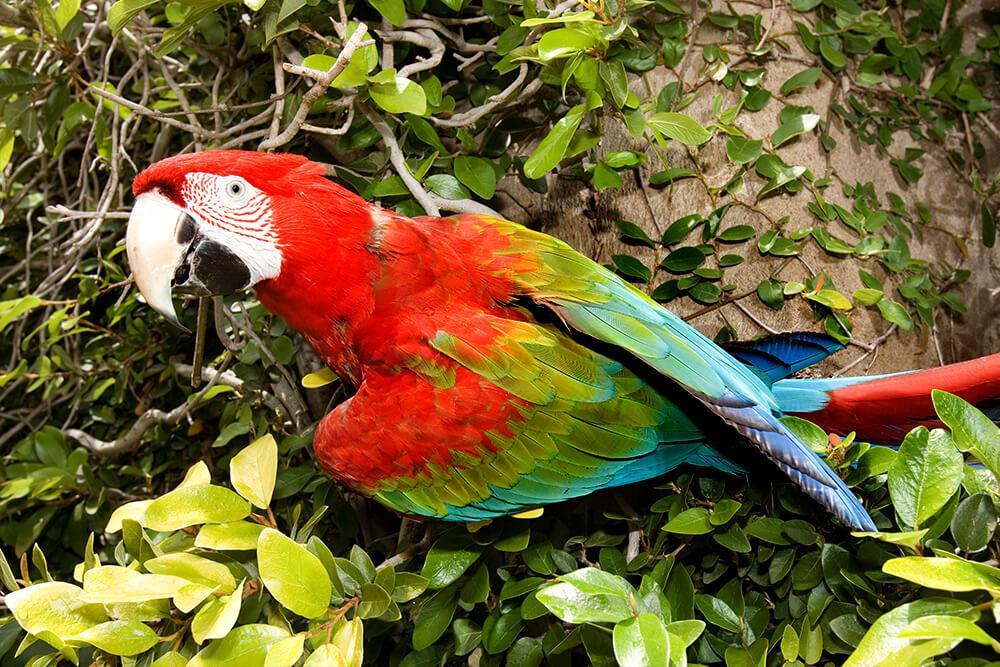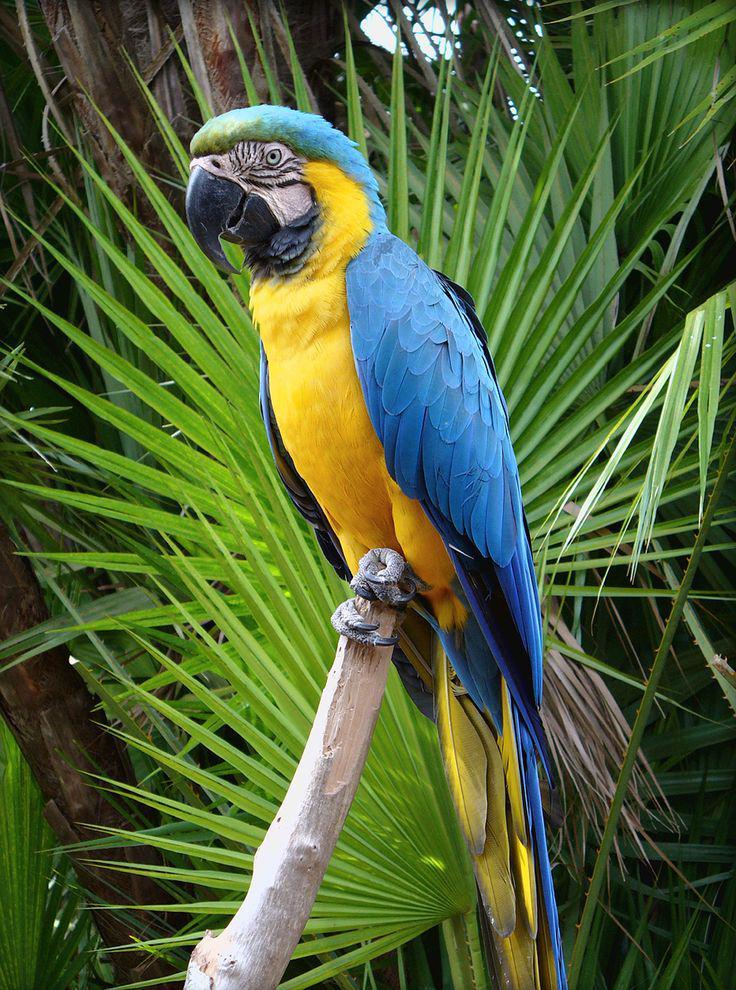The first image is the image on the left, the second image is the image on the right. Assess this claim about the two images: "There are at most two birds.". Correct or not? Answer yes or no. Yes. The first image is the image on the left, the second image is the image on the right. Given the left and right images, does the statement "There are several parrots, definitely more than two." hold true? Answer yes or no. No. 